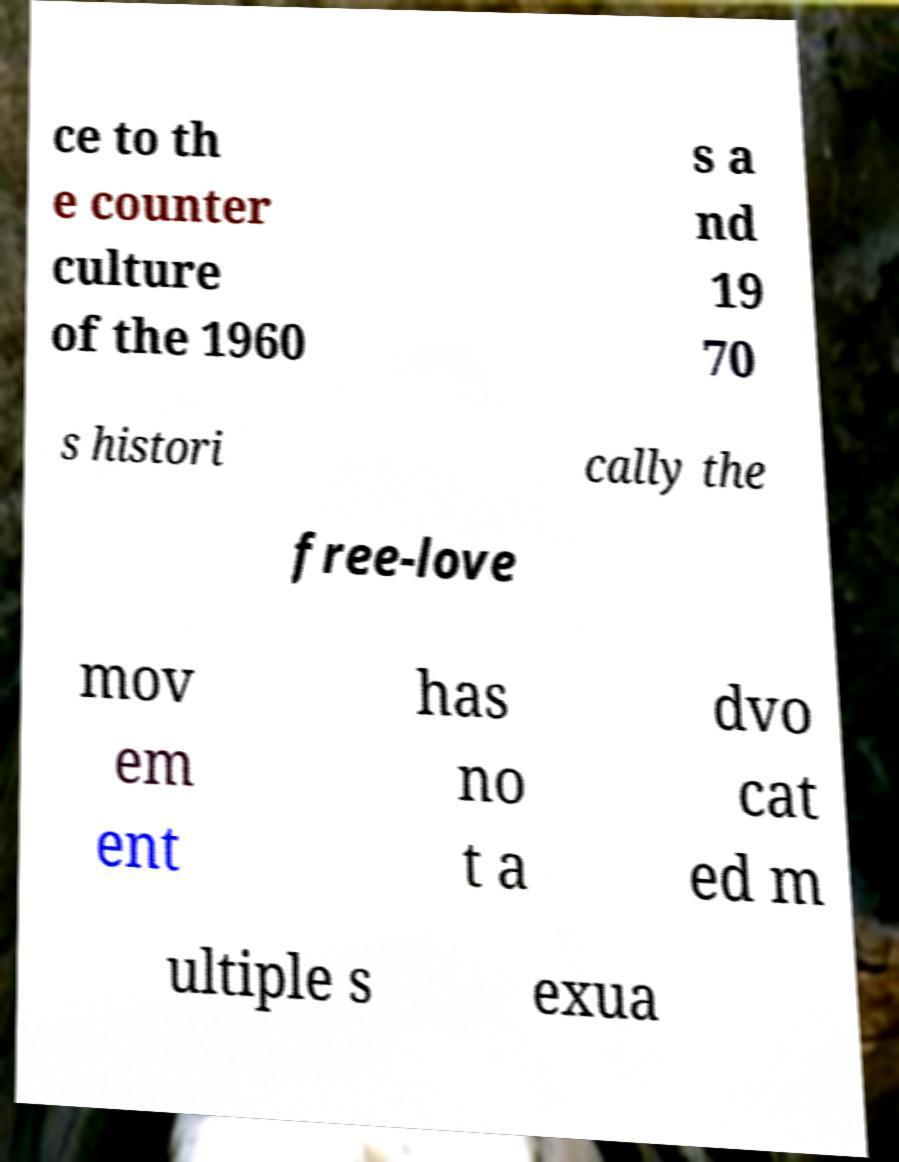What messages or text are displayed in this image? I need them in a readable, typed format. ce to th e counter culture of the 1960 s a nd 19 70 s histori cally the free-love mov em ent has no t a dvo cat ed m ultiple s exua 